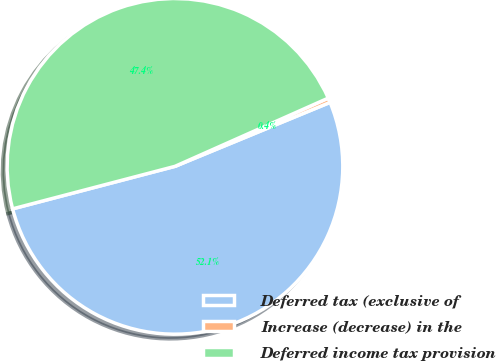Convert chart to OTSL. <chart><loc_0><loc_0><loc_500><loc_500><pie_chart><fcel>Deferred tax (exclusive of<fcel>Increase (decrease) in the<fcel>Deferred income tax provision<nl><fcel>52.15%<fcel>0.44%<fcel>47.41%<nl></chart> 